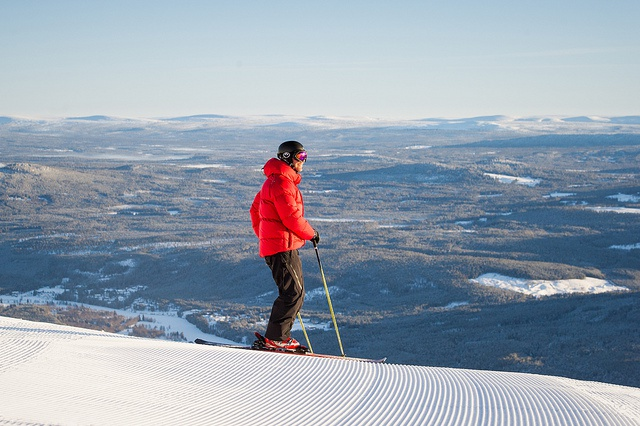Describe the objects in this image and their specific colors. I can see people in lightblue, red, black, brown, and salmon tones and skis in lightblue, black, darkgray, gray, and lightgray tones in this image. 